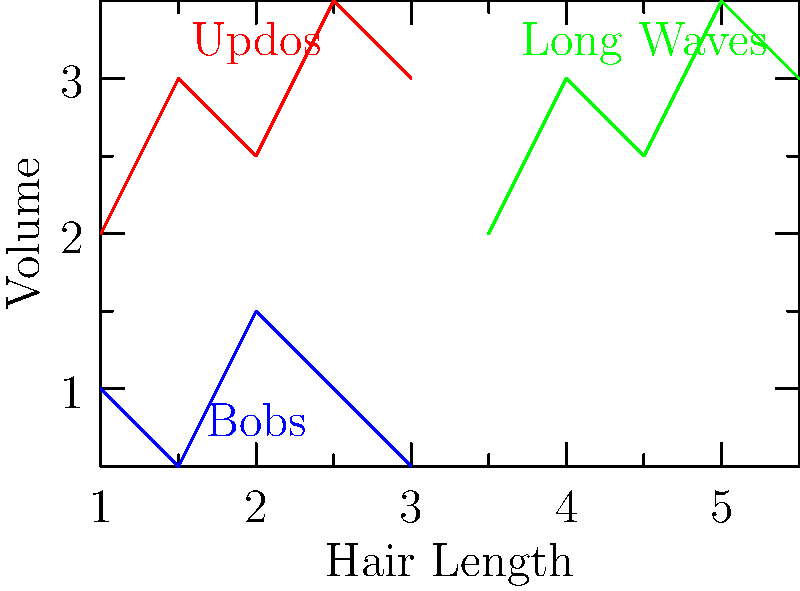In a beauty pageant, contestants' hairstyles are being analyzed using clustering techniques. The graph shows three clusters representing different hairstyle categories: Updos (red), Bobs (blue), and Long Waves (green). If a new contestant's hairstyle data point is plotted at (4, 1.5), which cluster is it most likely to belong to, and what clustering algorithm would be most appropriate for this scenario? To answer this question, let's follow these steps:

1. Analyze the graph:
   - Red cluster (Updos): Concentrated in the upper-left quadrant
   - Blue cluster (Bobs): Concentrated in the lower-left quadrant
   - Green cluster (Long Waves): Concentrated in the upper-right quadrant

2. Locate the new data point (4, 1.5):
   - It falls in the lower-right quadrant of the graph
   - It's closest to the green cluster (Long Waves) in terms of x-axis (hair length)
   - However, it's closer to the blue cluster (Bobs) in terms of y-axis (volume)

3. Determine the most likely cluster:
   - Based on the position, it's most likely to belong to the Long Waves cluster
   - This is because hair length seems to be the primary distinguishing factor between clusters

4. Choose an appropriate clustering algorithm:
   - K-means clustering would be suitable for this scenario because:
     a) The clusters appear to be roughly spherical
     b) The number of clusters is known (k = 3)
     c) It can handle numerical data well

5. Consider alternatives:
   - Hierarchical clustering could also work but might be less efficient for larger datasets
   - DBSCAN might not be ideal as the clusters don't have varying densities or irregular shapes

Therefore, the new data point (4, 1.5) is most likely to belong to the Long Waves cluster, and K-means clustering would be an appropriate algorithm for this scenario.
Answer: Long Waves cluster; K-means clustering 